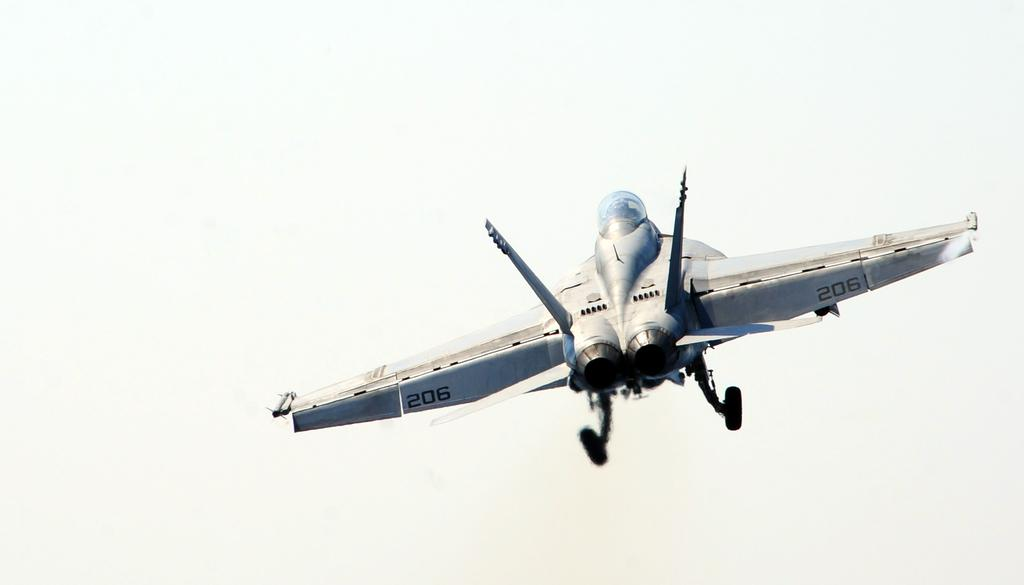What is the main subject of the image? The main subject of the image is an aircraft. What is the aircraft doing in the image? The aircraft is flying in the sky. What type of straw is being used by the rabbits in the image? There are no rabbits or straw present in the image; it features an aircraft flying in the sky. 